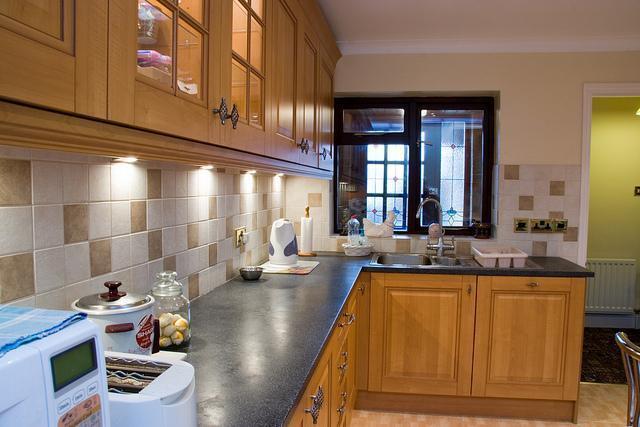What appliance is next to the microwave?
Choose the correct response and explain in the format: 'Answer: answer
Rationale: rationale.'
Options: Refrigerator, toaster, oven, dishwasher. Answer: toaster.
Rationale: You can see the slots where bread goes in on this object and it looks just like a toaster. 